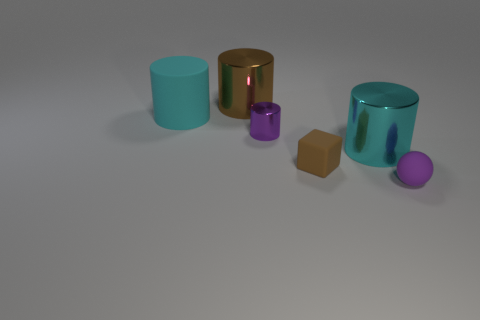Is the matte sphere the same color as the tiny metallic cylinder?
Your answer should be compact. Yes. Is there anything else of the same color as the block?
Provide a short and direct response. Yes. The metallic object that is the same color as the rubber cylinder is what shape?
Offer a very short reply. Cylinder. There is a purple object to the right of the tiny rubber block; what size is it?
Keep it short and to the point. Small. What is the shape of the purple matte object that is the same size as the purple shiny thing?
Keep it short and to the point. Sphere. Is the large cyan thing that is behind the cyan metal cylinder made of the same material as the tiny purple object that is on the right side of the tiny metallic cylinder?
Make the answer very short. Yes. The purple thing in front of the purple metallic object to the left of the tiny brown thing is made of what material?
Offer a very short reply. Rubber. What is the size of the cyan cylinder right of the cyan cylinder behind the big object on the right side of the brown metal object?
Make the answer very short. Large. Do the ball and the brown metal cylinder have the same size?
Provide a short and direct response. No. Is the shape of the small purple thing that is to the left of the tiny brown rubber object the same as the large shiny object behind the tiny purple shiny cylinder?
Provide a succinct answer. Yes. 